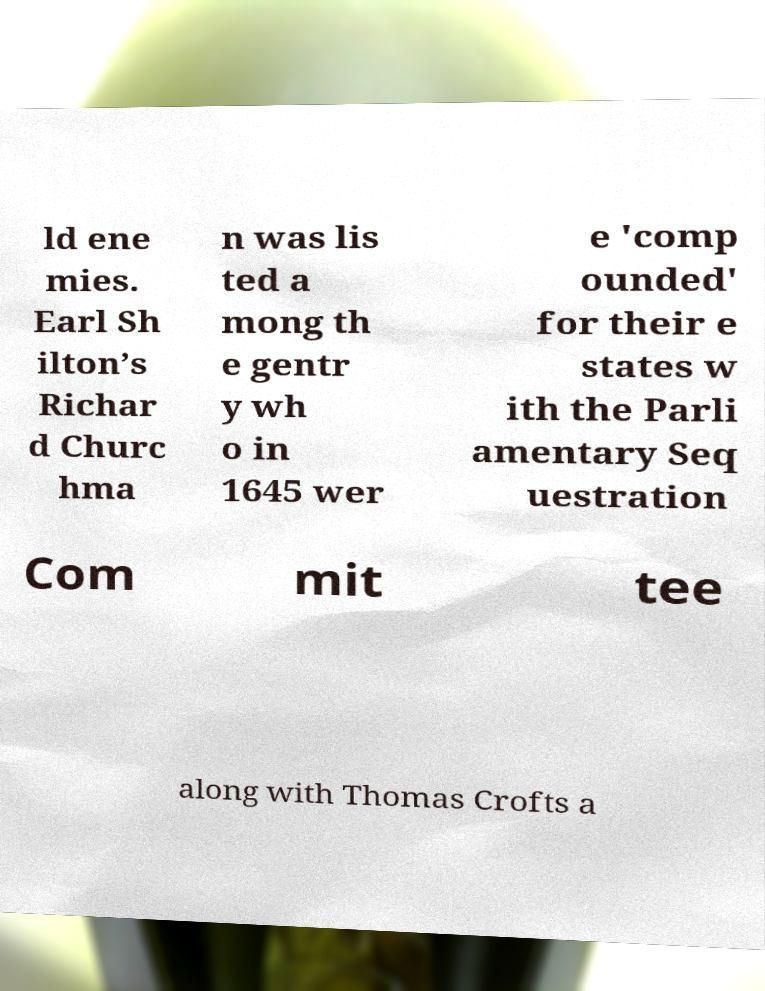Can you accurately transcribe the text from the provided image for me? ld ene mies. Earl Sh ilton’s Richar d Churc hma n was lis ted a mong th e gentr y wh o in 1645 wer e 'comp ounded' for their e states w ith the Parli amentary Seq uestration Com mit tee along with Thomas Crofts a 